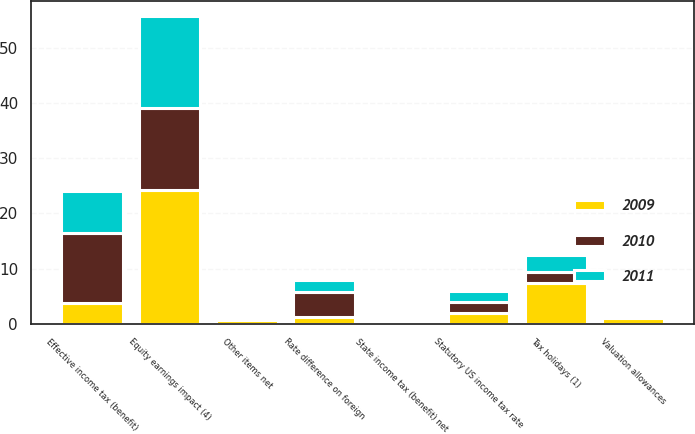Convert chart. <chart><loc_0><loc_0><loc_500><loc_500><stacked_bar_chart><ecel><fcel>Statutory US income tax rate<fcel>State income tax (benefit) net<fcel>Tax holidays (1)<fcel>Rate difference on foreign<fcel>Equity earnings impact (4)<fcel>Valuation allowances<fcel>Other items net<fcel>Effective income tax (benefit)<nl><fcel>2010<fcel>2<fcel>0.1<fcel>2<fcel>4.6<fcel>14.9<fcel>0.5<fcel>0.3<fcel>12.7<nl><fcel>2011<fcel>2<fcel>0.1<fcel>3.1<fcel>2.2<fcel>16.6<fcel>0.1<fcel>0.2<fcel>7.5<nl><fcel>2009<fcel>2<fcel>0.5<fcel>7.3<fcel>1.2<fcel>24.2<fcel>1<fcel>0.6<fcel>3.8<nl></chart> 